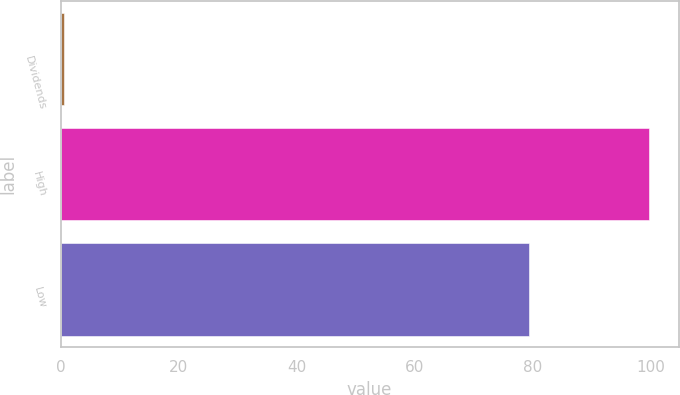Convert chart to OTSL. <chart><loc_0><loc_0><loc_500><loc_500><bar_chart><fcel>Dividends<fcel>High<fcel>Low<nl><fcel>0.55<fcel>99.71<fcel>79.31<nl></chart> 